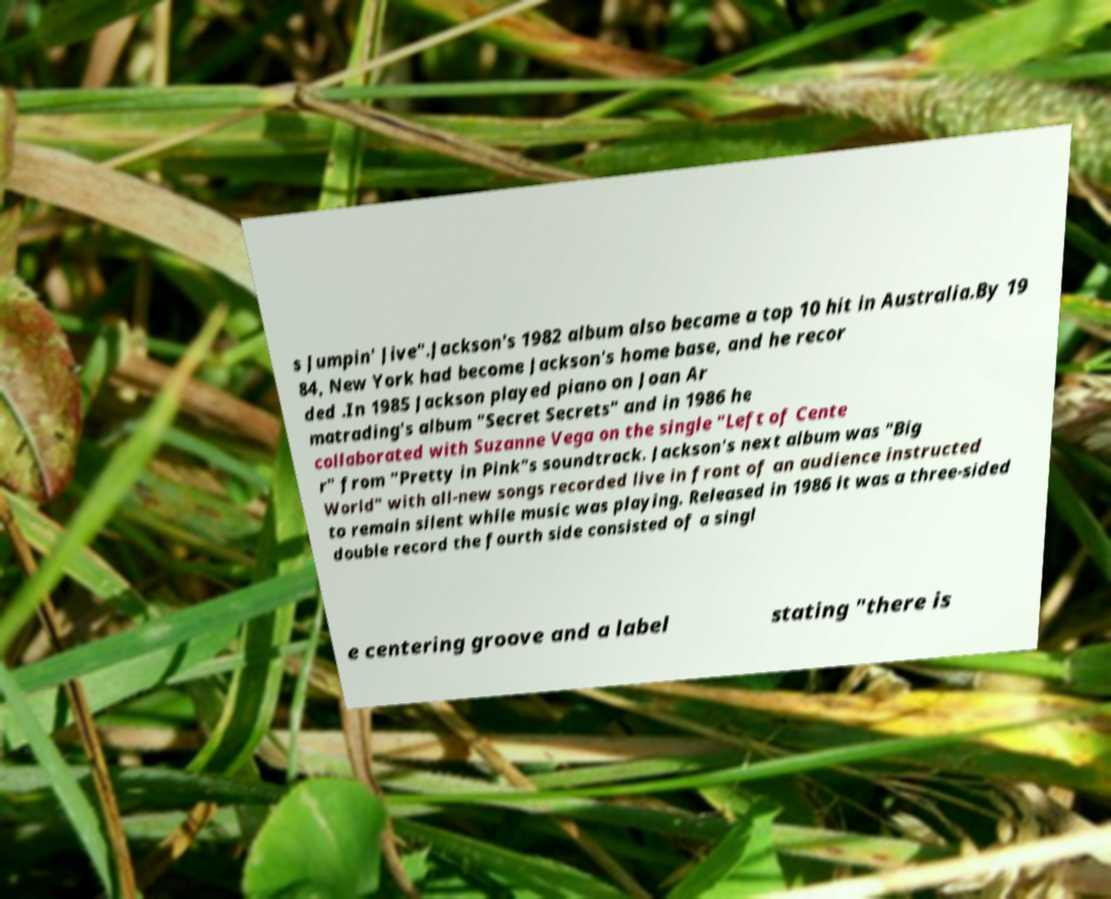I need the written content from this picture converted into text. Can you do that? s Jumpin' Jive".Jackson's 1982 album also became a top 10 hit in Australia.By 19 84, New York had become Jackson's home base, and he recor ded .In 1985 Jackson played piano on Joan Ar matrading's album "Secret Secrets" and in 1986 he collaborated with Suzanne Vega on the single "Left of Cente r" from "Pretty in Pink"s soundtrack. Jackson's next album was "Big World" with all-new songs recorded live in front of an audience instructed to remain silent while music was playing. Released in 1986 it was a three-sided double record the fourth side consisted of a singl e centering groove and a label stating "there is 